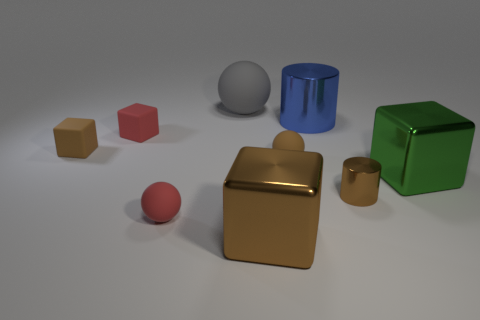Subtract all yellow balls. How many brown cubes are left? 2 Subtract all small brown blocks. How many blocks are left? 3 Subtract all green blocks. How many blocks are left? 3 Subtract all balls. How many objects are left? 6 Add 1 small blue rubber cubes. How many small blue rubber cubes exist? 1 Subtract 0 blue spheres. How many objects are left? 9 Subtract all gray cubes. Subtract all purple spheres. How many cubes are left? 4 Subtract all tiny brown metal objects. Subtract all tiny things. How many objects are left? 3 Add 3 tiny shiny things. How many tiny shiny things are left? 4 